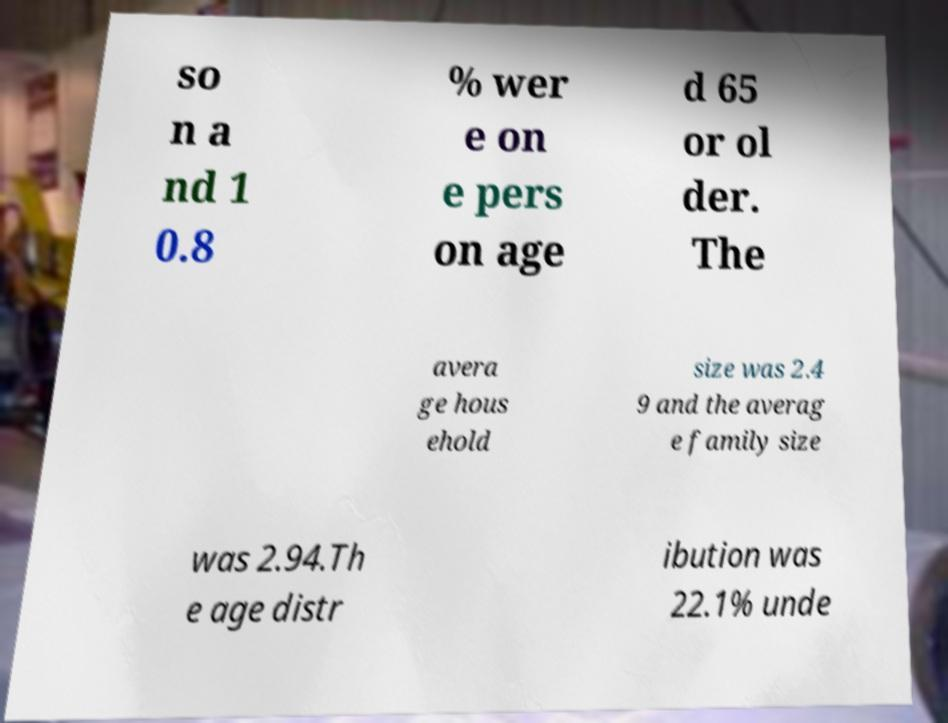Could you assist in decoding the text presented in this image and type it out clearly? so n a nd 1 0.8 % wer e on e pers on age d 65 or ol der. The avera ge hous ehold size was 2.4 9 and the averag e family size was 2.94.Th e age distr ibution was 22.1% unde 